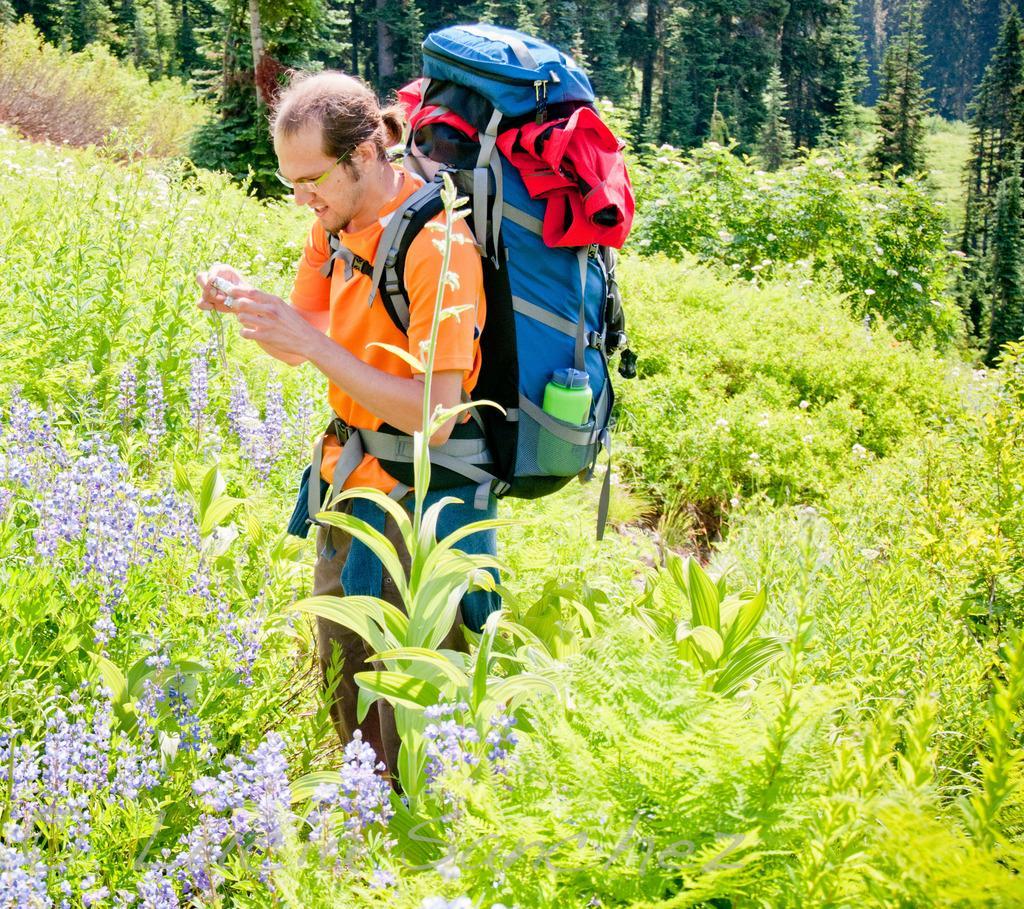Describe this image in one or two sentences. In this image, In the middle there is a man standing and he is carrying a blue color bag, In that there are some red color clothes in the bag, There are some green color plants and green color trees in the background. 